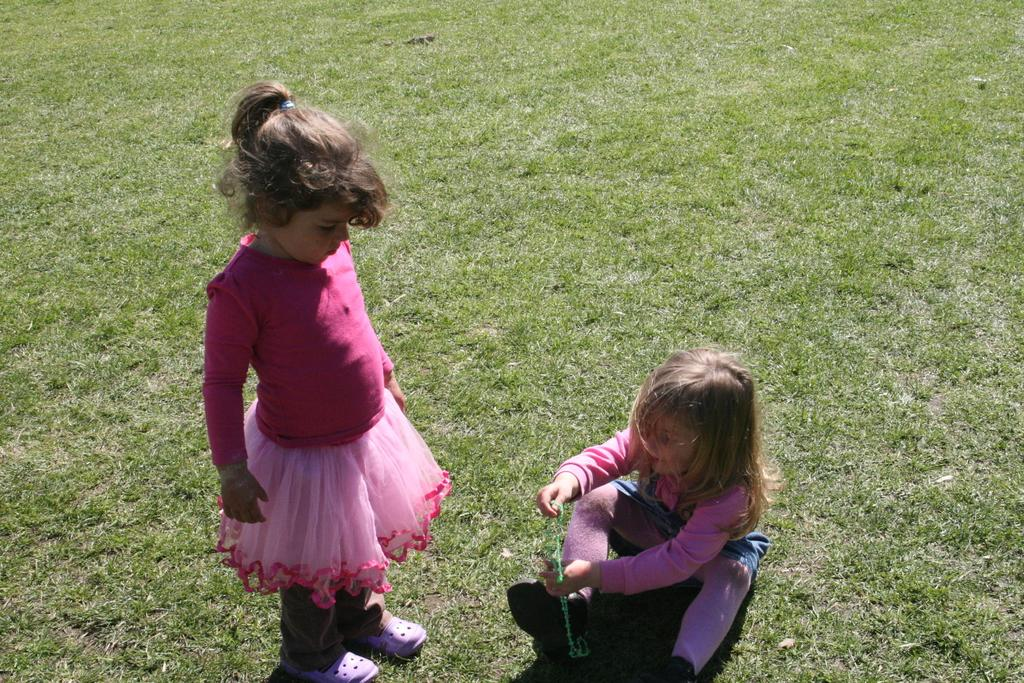How many girls are in the image? There are two girls in the image. What are the positions of the girls in the image? One girl is seated, and the other is standing. What is the ground made of in the image? There is grass on the ground in the image. What color is the clothing of the girl wearing a frock? The girl wearing a pink frock is wearing a pink frock. What color is the clothing of the other girl? The other girl is wearing a pink dress. What type of punishment is the girl receiving from the horse in the image? There is no horse present in the image, and therefore no such punishment can be observed. 